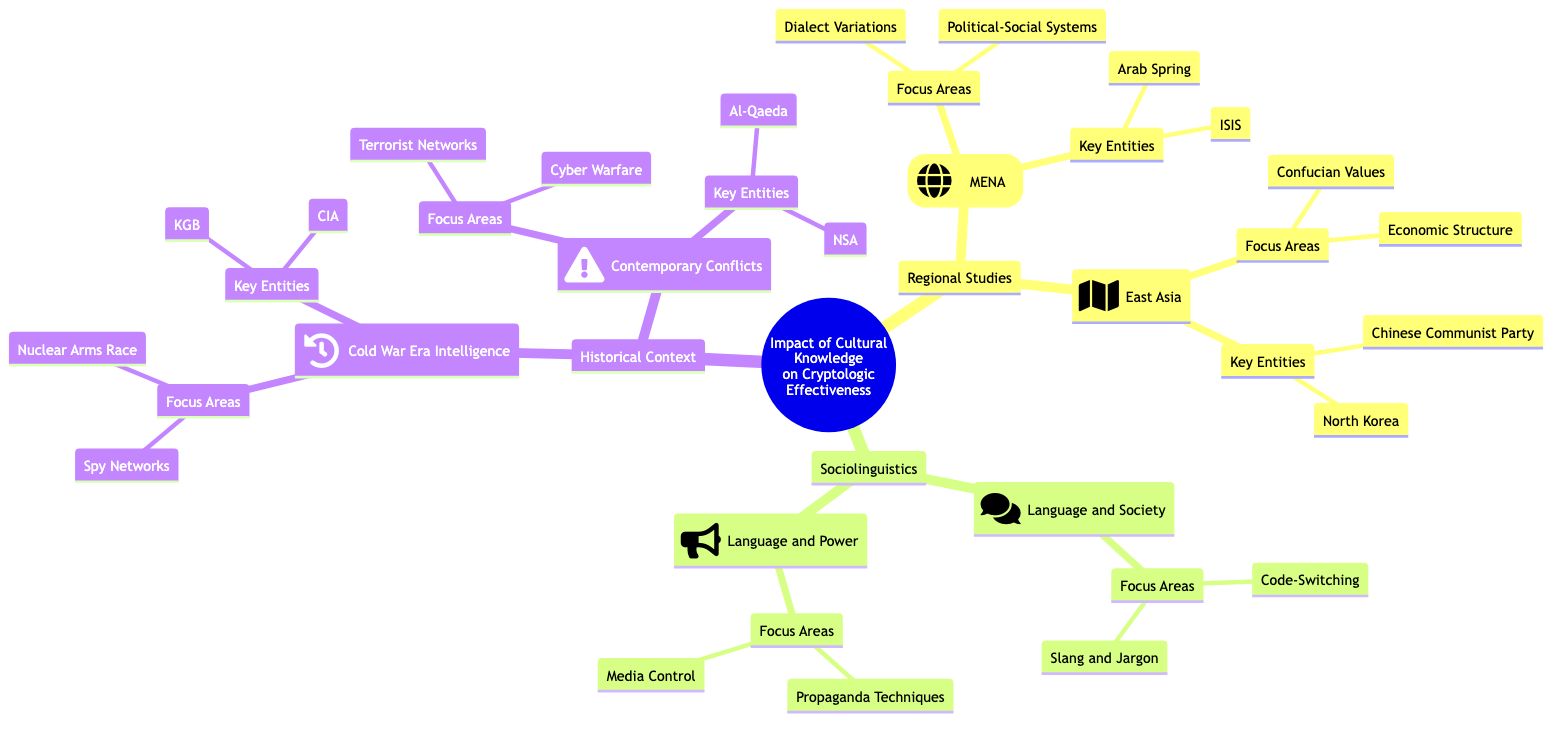What are the focus areas listed under Middle East and North Africa? The focus areas under Middle East and North Africa include "Dialect Variations" and "Political-Social Systems." This information can be found directly under the "Middle East and North Africa (MENA)" node in the diagram.
Answer: Dialect Variations, Political-Social Systems How many key entities are listed for East Asia? The East Asia section has two key entities: "Chinese Communist Party" and "North Korea." By counting these listed entities directly, we note the total is two.
Answer: 2 What are the focus areas for Sociolinguistics under Language and Society? The focus areas for the "Language and Society" section under Sociolinguistics are "Code-Switching" and "Slang and Jargon." These are specified directly in the corresponding section.
Answer: Code-Switching, Slang and Jargon Which historical context focuses on Cyber Warfare? The "Contemporary Conflicts" under Historical Context pertains to Cyber Warfare. This can be traced by identifying the focus areas associated with "Contemporary Conflicts."
Answer: Contemporary Conflicts What key entities are associated with Cold War Era Intelligence? The key entities discussed in the context of Cold War Era Intelligence are "CIA" and "KGB." This information is derived from the list of key entities directly under this category in the diagram.
Answer: CIA, KGB What is the relationship between Regional Studies and Sociolinguistics in the diagram? Regional Studies and Sociolinguistics are both primary branches under the overarching concept "Impact of Cultural Knowledge on Cryptologic Effectiveness." This shows that both categories are important areas impacting the main theme of the concept map.
Answer: Both are branches Which key entity is listed for Contemporary Conflicts? The key entity listed under "Contemporary Conflicts" is "Al-Qaeda." This can be confirmed by looking at the key entities listed under that section of the historical context.
Answer: Al-Qaeda What focus area is unique to East Asia compared to MENA? "Confucian Values" is a focus area unique to East Asia compared to MENA, which has different focus areas. This distinction is made clear by examining the focus areas listed under each regional study separately.
Answer: Confucian Values How many total focus areas are associated with Historical Context? Historical Context has a total of four focus areas: "Nuclear Arms Race," "Spy Networks," "Cyber Warfare," and "Terrorist Networks." By counting the focus areas listed in both Cold War Era Intelligence and Contemporary Conflicts, we arrive at a total of four.
Answer: 4 